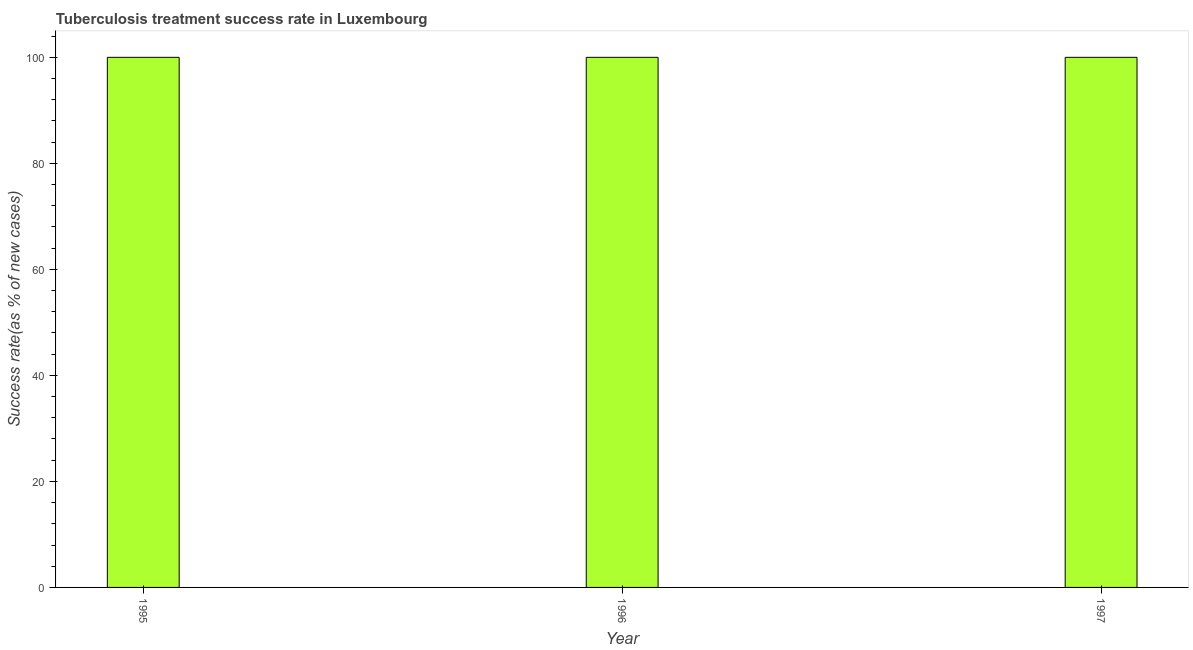Does the graph contain grids?
Your response must be concise. No. What is the title of the graph?
Your answer should be very brief. Tuberculosis treatment success rate in Luxembourg. What is the label or title of the Y-axis?
Make the answer very short. Success rate(as % of new cases). What is the tuberculosis treatment success rate in 1996?
Provide a short and direct response. 100. Across all years, what is the minimum tuberculosis treatment success rate?
Keep it short and to the point. 100. In which year was the tuberculosis treatment success rate maximum?
Offer a very short reply. 1995. What is the sum of the tuberculosis treatment success rate?
Make the answer very short. 300. Is the tuberculosis treatment success rate in 1996 less than that in 1997?
Give a very brief answer. No. Is the difference between the tuberculosis treatment success rate in 1996 and 1997 greater than the difference between any two years?
Your response must be concise. Yes. Is the sum of the tuberculosis treatment success rate in 1995 and 1996 greater than the maximum tuberculosis treatment success rate across all years?
Your response must be concise. Yes. What is the difference between the highest and the lowest tuberculosis treatment success rate?
Provide a short and direct response. 0. Are the values on the major ticks of Y-axis written in scientific E-notation?
Offer a very short reply. No. What is the Success rate(as % of new cases) of 1995?
Your response must be concise. 100. What is the Success rate(as % of new cases) in 1997?
Provide a succinct answer. 100. What is the ratio of the Success rate(as % of new cases) in 1995 to that in 1996?
Provide a succinct answer. 1. What is the ratio of the Success rate(as % of new cases) in 1995 to that in 1997?
Your response must be concise. 1. 